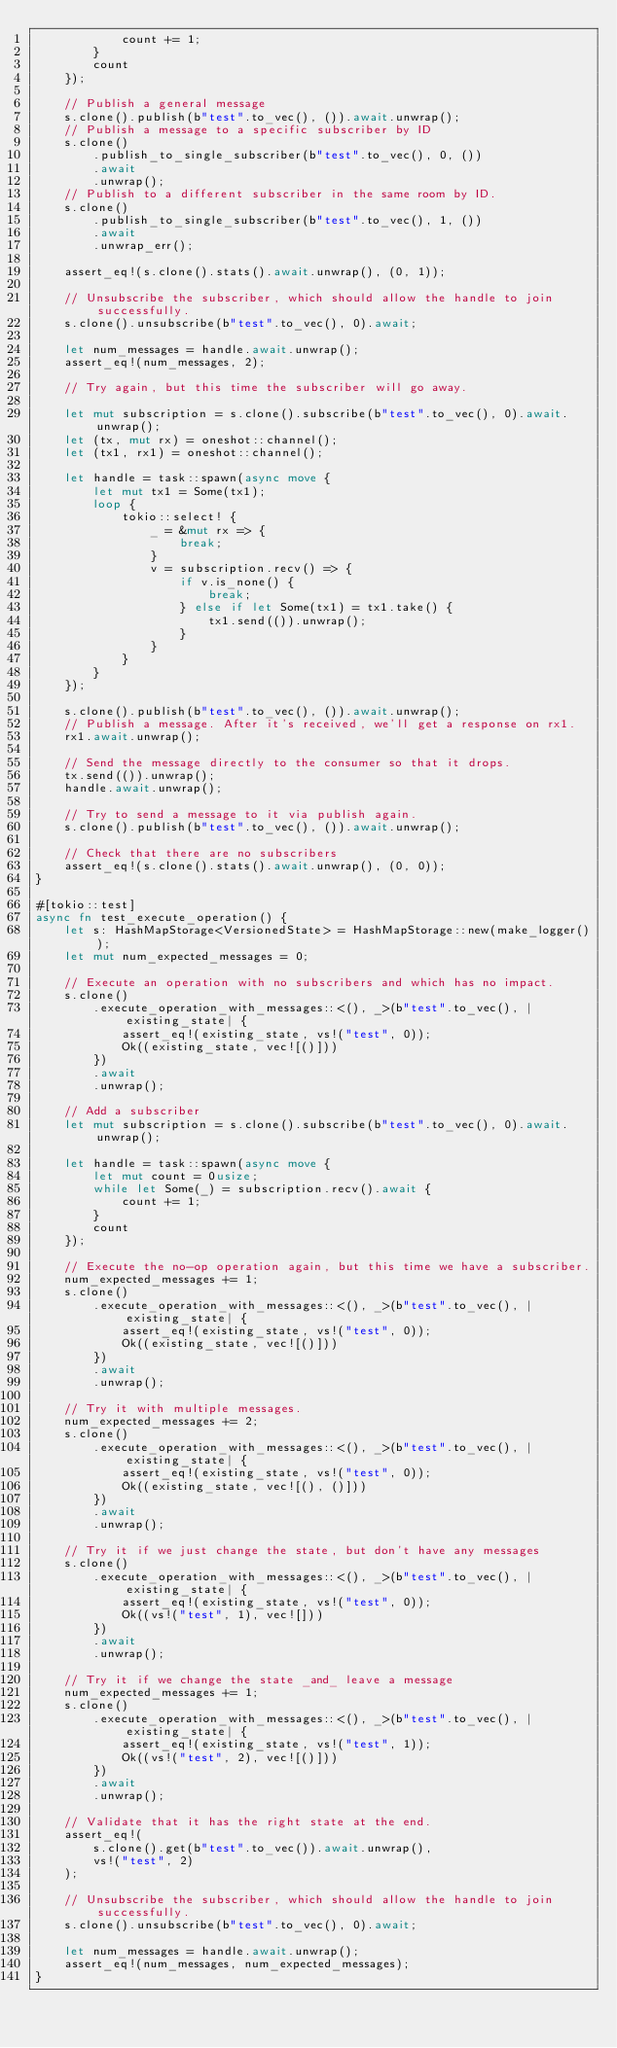<code> <loc_0><loc_0><loc_500><loc_500><_Rust_>            count += 1;
        }
        count
    });

    // Publish a general message
    s.clone().publish(b"test".to_vec(), ()).await.unwrap();
    // Publish a message to a specific subscriber by ID
    s.clone()
        .publish_to_single_subscriber(b"test".to_vec(), 0, ())
        .await
        .unwrap();
    // Publish to a different subscriber in the same room by ID.
    s.clone()
        .publish_to_single_subscriber(b"test".to_vec(), 1, ())
        .await
        .unwrap_err();

    assert_eq!(s.clone().stats().await.unwrap(), (0, 1));

    // Unsubscribe the subscriber, which should allow the handle to join successfully.
    s.clone().unsubscribe(b"test".to_vec(), 0).await;

    let num_messages = handle.await.unwrap();
    assert_eq!(num_messages, 2);

    // Try again, but this time the subscriber will go away.

    let mut subscription = s.clone().subscribe(b"test".to_vec(), 0).await.unwrap();
    let (tx, mut rx) = oneshot::channel();
    let (tx1, rx1) = oneshot::channel();

    let handle = task::spawn(async move {
        let mut tx1 = Some(tx1);
        loop {
            tokio::select! {
                _ = &mut rx => {
                    break;
                }
                v = subscription.recv() => {
                    if v.is_none() {
                        break;
                    } else if let Some(tx1) = tx1.take() {
                        tx1.send(()).unwrap();
                    }
                }
            }
        }
    });

    s.clone().publish(b"test".to_vec(), ()).await.unwrap();
    // Publish a message. After it's received, we'll get a response on rx1.
    rx1.await.unwrap();

    // Send the message directly to the consumer so that it drops.
    tx.send(()).unwrap();
    handle.await.unwrap();

    // Try to send a message to it via publish again.
    s.clone().publish(b"test".to_vec(), ()).await.unwrap();

    // Check that there are no subscribers
    assert_eq!(s.clone().stats().await.unwrap(), (0, 0));
}

#[tokio::test]
async fn test_execute_operation() {
    let s: HashMapStorage<VersionedState> = HashMapStorage::new(make_logger());
    let mut num_expected_messages = 0;

    // Execute an operation with no subscribers and which has no impact.
    s.clone()
        .execute_operation_with_messages::<(), _>(b"test".to_vec(), |existing_state| {
            assert_eq!(existing_state, vs!("test", 0));
            Ok((existing_state, vec![()]))
        })
        .await
        .unwrap();

    // Add a subscriber
    let mut subscription = s.clone().subscribe(b"test".to_vec(), 0).await.unwrap();

    let handle = task::spawn(async move {
        let mut count = 0usize;
        while let Some(_) = subscription.recv().await {
            count += 1;
        }
        count
    });

    // Execute the no-op operation again, but this time we have a subscriber.
    num_expected_messages += 1;
    s.clone()
        .execute_operation_with_messages::<(), _>(b"test".to_vec(), |existing_state| {
            assert_eq!(existing_state, vs!("test", 0));
            Ok((existing_state, vec![()]))
        })
        .await
        .unwrap();

    // Try it with multiple messages.
    num_expected_messages += 2;
    s.clone()
        .execute_operation_with_messages::<(), _>(b"test".to_vec(), |existing_state| {
            assert_eq!(existing_state, vs!("test", 0));
            Ok((existing_state, vec![(), ()]))
        })
        .await
        .unwrap();

    // Try it if we just change the state, but don't have any messages
    s.clone()
        .execute_operation_with_messages::<(), _>(b"test".to_vec(), |existing_state| {
            assert_eq!(existing_state, vs!("test", 0));
            Ok((vs!("test", 1), vec![]))
        })
        .await
        .unwrap();

    // Try it if we change the state _and_ leave a message
    num_expected_messages += 1;
    s.clone()
        .execute_operation_with_messages::<(), _>(b"test".to_vec(), |existing_state| {
            assert_eq!(existing_state, vs!("test", 1));
            Ok((vs!("test", 2), vec![()]))
        })
        .await
        .unwrap();

    // Validate that it has the right state at the end.
    assert_eq!(
        s.clone().get(b"test".to_vec()).await.unwrap(),
        vs!("test", 2)
    );

    // Unsubscribe the subscriber, which should allow the handle to join successfully.
    s.clone().unsubscribe(b"test".to_vec(), 0).await;

    let num_messages = handle.await.unwrap();
    assert_eq!(num_messages, num_expected_messages);
}
</code> 